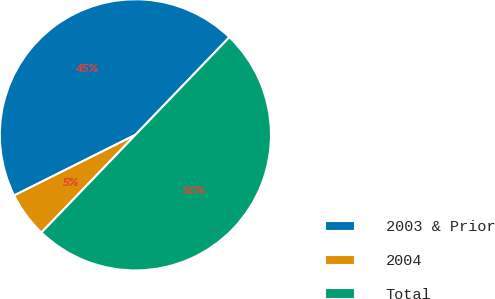Convert chart. <chart><loc_0><loc_0><loc_500><loc_500><pie_chart><fcel>2003 & Prior<fcel>2004<fcel>Total<nl><fcel>44.57%<fcel>5.43%<fcel>50.0%<nl></chart> 